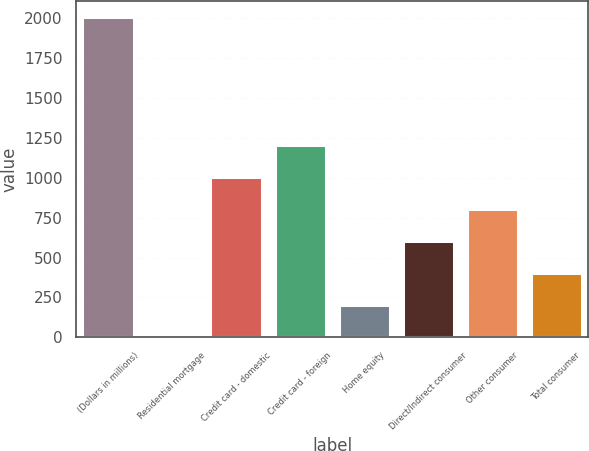<chart> <loc_0><loc_0><loc_500><loc_500><bar_chart><fcel>(Dollars in millions)<fcel>Residential mortgage<fcel>Credit card - domestic<fcel>Credit card - foreign<fcel>Home equity<fcel>Direct/Indirect consumer<fcel>Other consumer<fcel>Total consumer<nl><fcel>2006<fcel>0.02<fcel>1003.02<fcel>1203.62<fcel>200.62<fcel>601.82<fcel>802.42<fcel>401.22<nl></chart> 